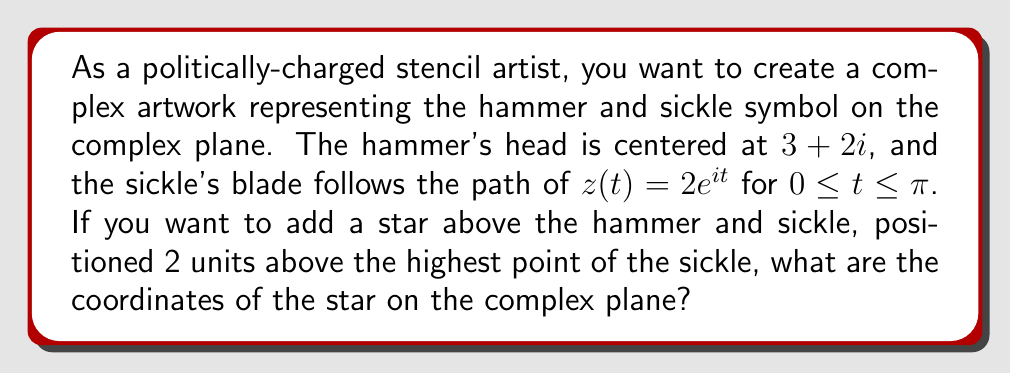Provide a solution to this math problem. To solve this problem, let's follow these steps:

1) First, we need to find the highest point of the sickle. The sickle follows the path $z(t) = 2e^{it}$ for $0 \leq t \leq \pi$.

2) The highest point will occur when the imaginary part is at its maximum. This happens when $t = \frac{\pi}{2}$.

3) At $t = \frac{\pi}{2}$, $z(\frac{\pi}{2}) = 2e^{i\frac{\pi}{2}} = 2i$

4) So the highest point of the sickle is at $2i$ on the complex plane.

5) The star needs to be positioned 2 units above this highest point.

6) On the complex plane, moving "up" means adding to the imaginary part.

7) Therefore, the position of the star will be:
   $2i + 2i = 4i$

Thus, the coordinates of the star on the complex plane are $0+4i$ or simply $4i$.
Answer: $4i$ 